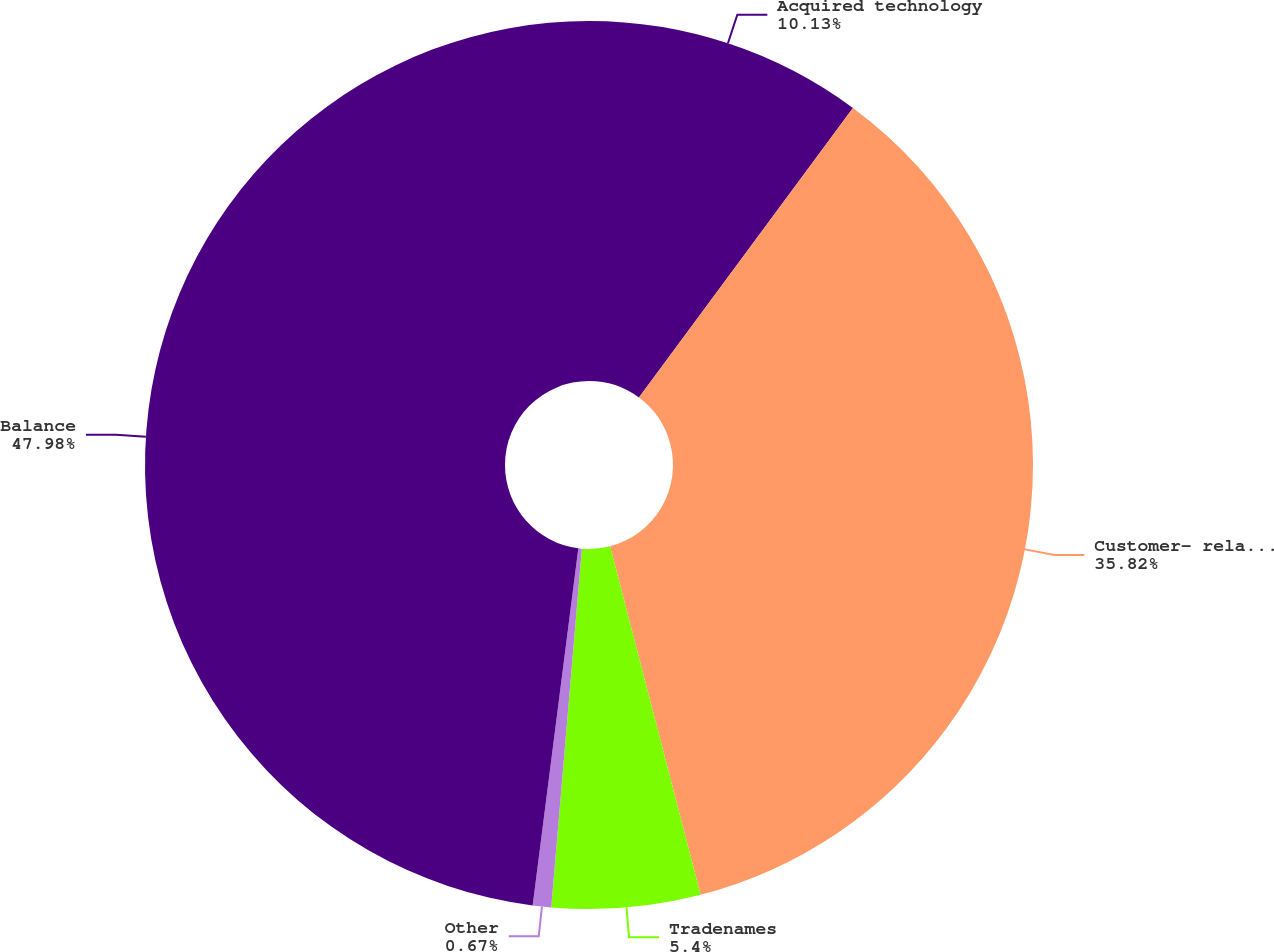Convert chart to OTSL. <chart><loc_0><loc_0><loc_500><loc_500><pie_chart><fcel>Acquired technology<fcel>Customer- related intangibles<fcel>Tradenames<fcel>Other<fcel>Balance<nl><fcel>10.13%<fcel>35.82%<fcel>5.4%<fcel>0.67%<fcel>47.97%<nl></chart> 